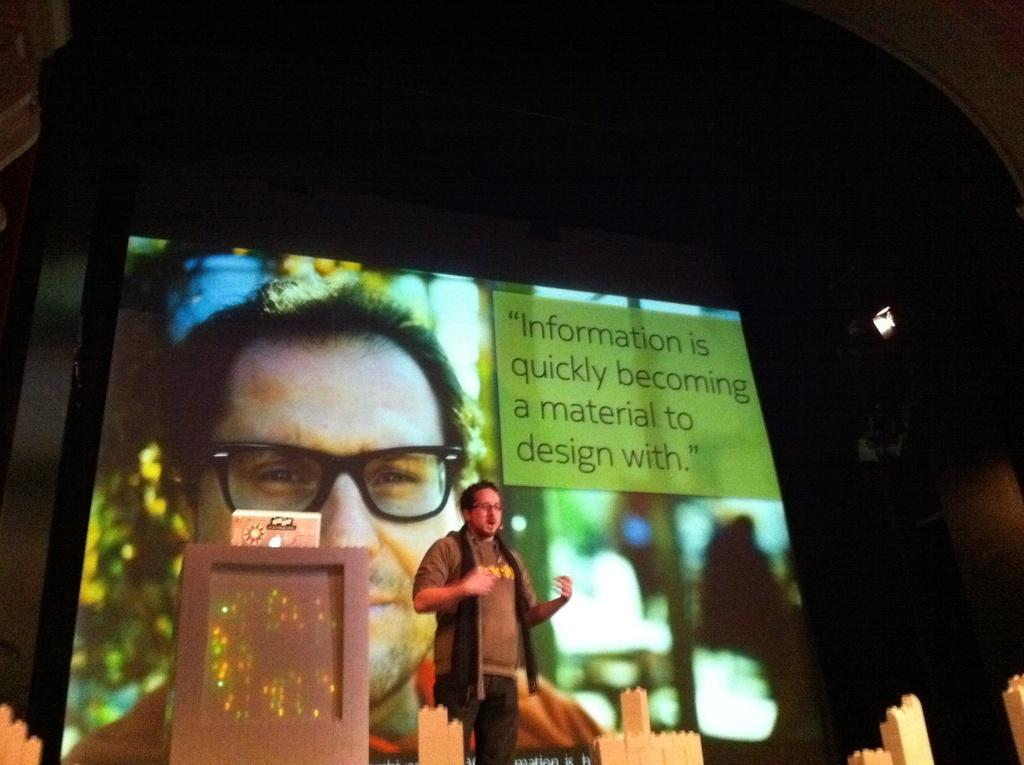Could you give a brief overview of what you see in this image? In the image we can see a man standing, wearing clothes, spectacles and it looks like he is talking. Here we can see the podium, projected screen and the background is dark. 